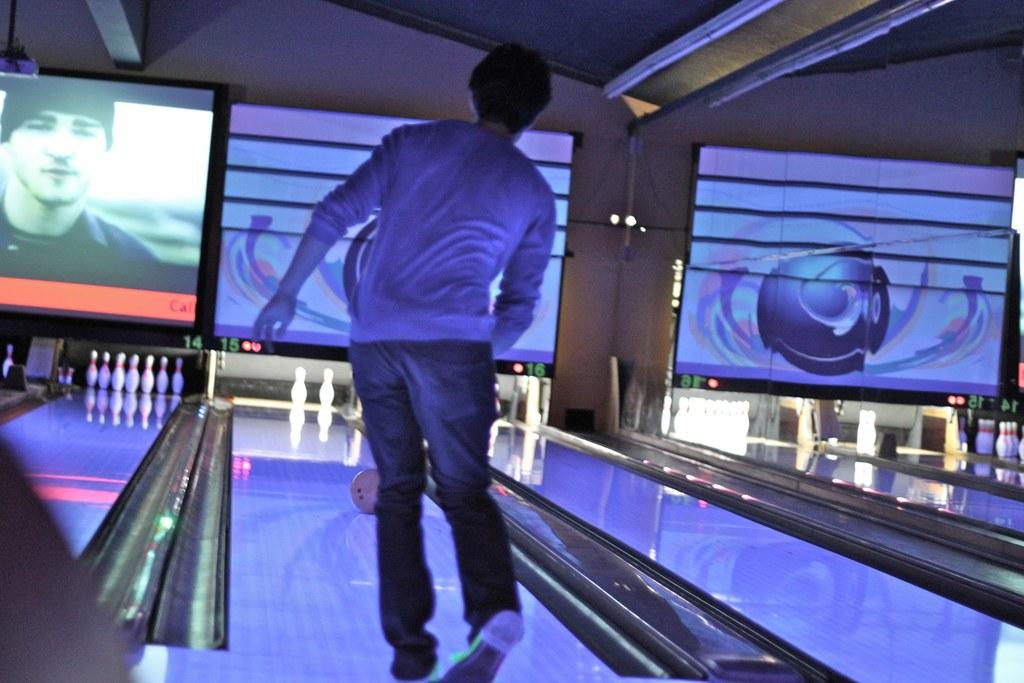What is the main subject of the image? There is a person standing in the image. What objects related to bowling can be seen in the image? There is a bowling ball and bowling pins in the image. What type of equipment is present for monitoring or displaying information? There are screens in the image. What can be seen in the background of the image? There is a wall in the background of the image. What type of wrist support is the person using in the image? There is no wrist support visible in the image. Who is the owner of the bowling alley in the image? The image does not provide information about the ownership of the bowling alley. 